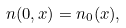<formula> <loc_0><loc_0><loc_500><loc_500>n ( 0 , x ) = n _ { 0 } ( x ) ,</formula> 